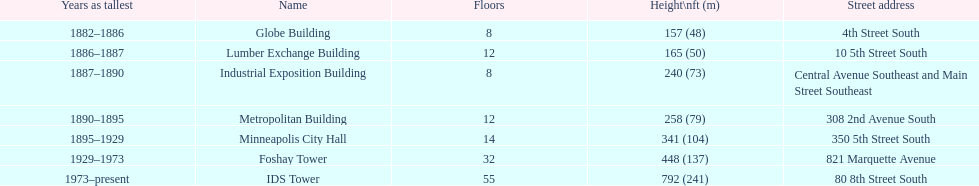Help me parse the entirety of this table. {'header': ['Years as tallest', 'Name', 'Floors', 'Height\\nft (m)', 'Street address'], 'rows': [['1882–1886', 'Globe Building', '8', '157 (48)', '4th Street South'], ['1886–1887', 'Lumber Exchange Building', '12', '165 (50)', '10 5th Street South'], ['1887–1890', 'Industrial Exposition Building', '8', '240 (73)', 'Central Avenue Southeast and Main Street Southeast'], ['1890–1895', 'Metropolitan Building', '12', '258 (79)', '308 2nd Avenue South'], ['1895–1929', 'Minneapolis City Hall', '14', '341 (104)', '350 5th Street South'], ['1929–1973', 'Foshay Tower', '32', '448 (137)', '821 Marquette Avenue'], ['1973–present', 'IDS Tower', '55', '792 (241)', '80 8th Street South']]} How many floors does the foshay tower have? 32. 